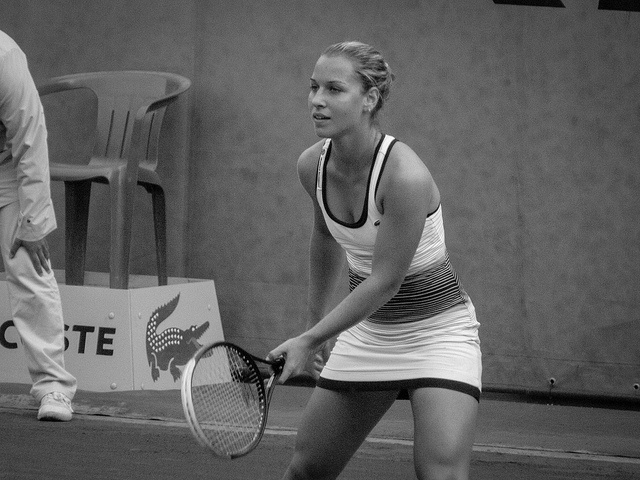Describe the objects in this image and their specific colors. I can see people in black, gray, darkgray, and lightgray tones, chair in gray and black tones, people in black, darkgray, gray, and lightgray tones, and tennis racket in black, gray, darkgray, and lightgray tones in this image. 